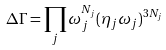<formula> <loc_0><loc_0><loc_500><loc_500>\Delta \Gamma = \prod _ { j } \omega _ { j } ^ { N _ { j } } ( \eta _ { j } \omega _ { j } ) ^ { 3 N _ { j } }</formula> 